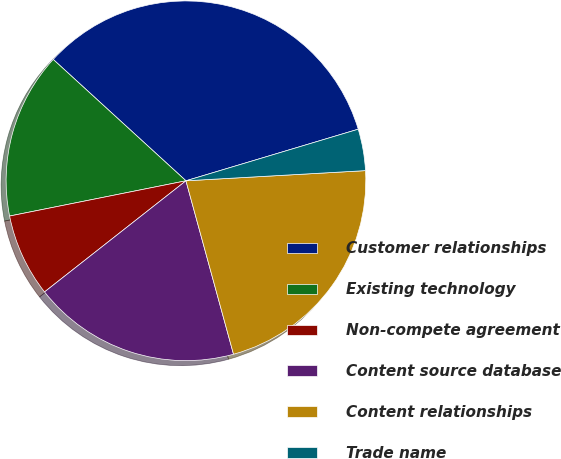<chart> <loc_0><loc_0><loc_500><loc_500><pie_chart><fcel>Customer relationships<fcel>Existing technology<fcel>Non-compete agreement<fcel>Content source database<fcel>Content relationships<fcel>Trade name<nl><fcel>33.58%<fcel>14.93%<fcel>7.46%<fcel>18.66%<fcel>21.64%<fcel>3.73%<nl></chart> 